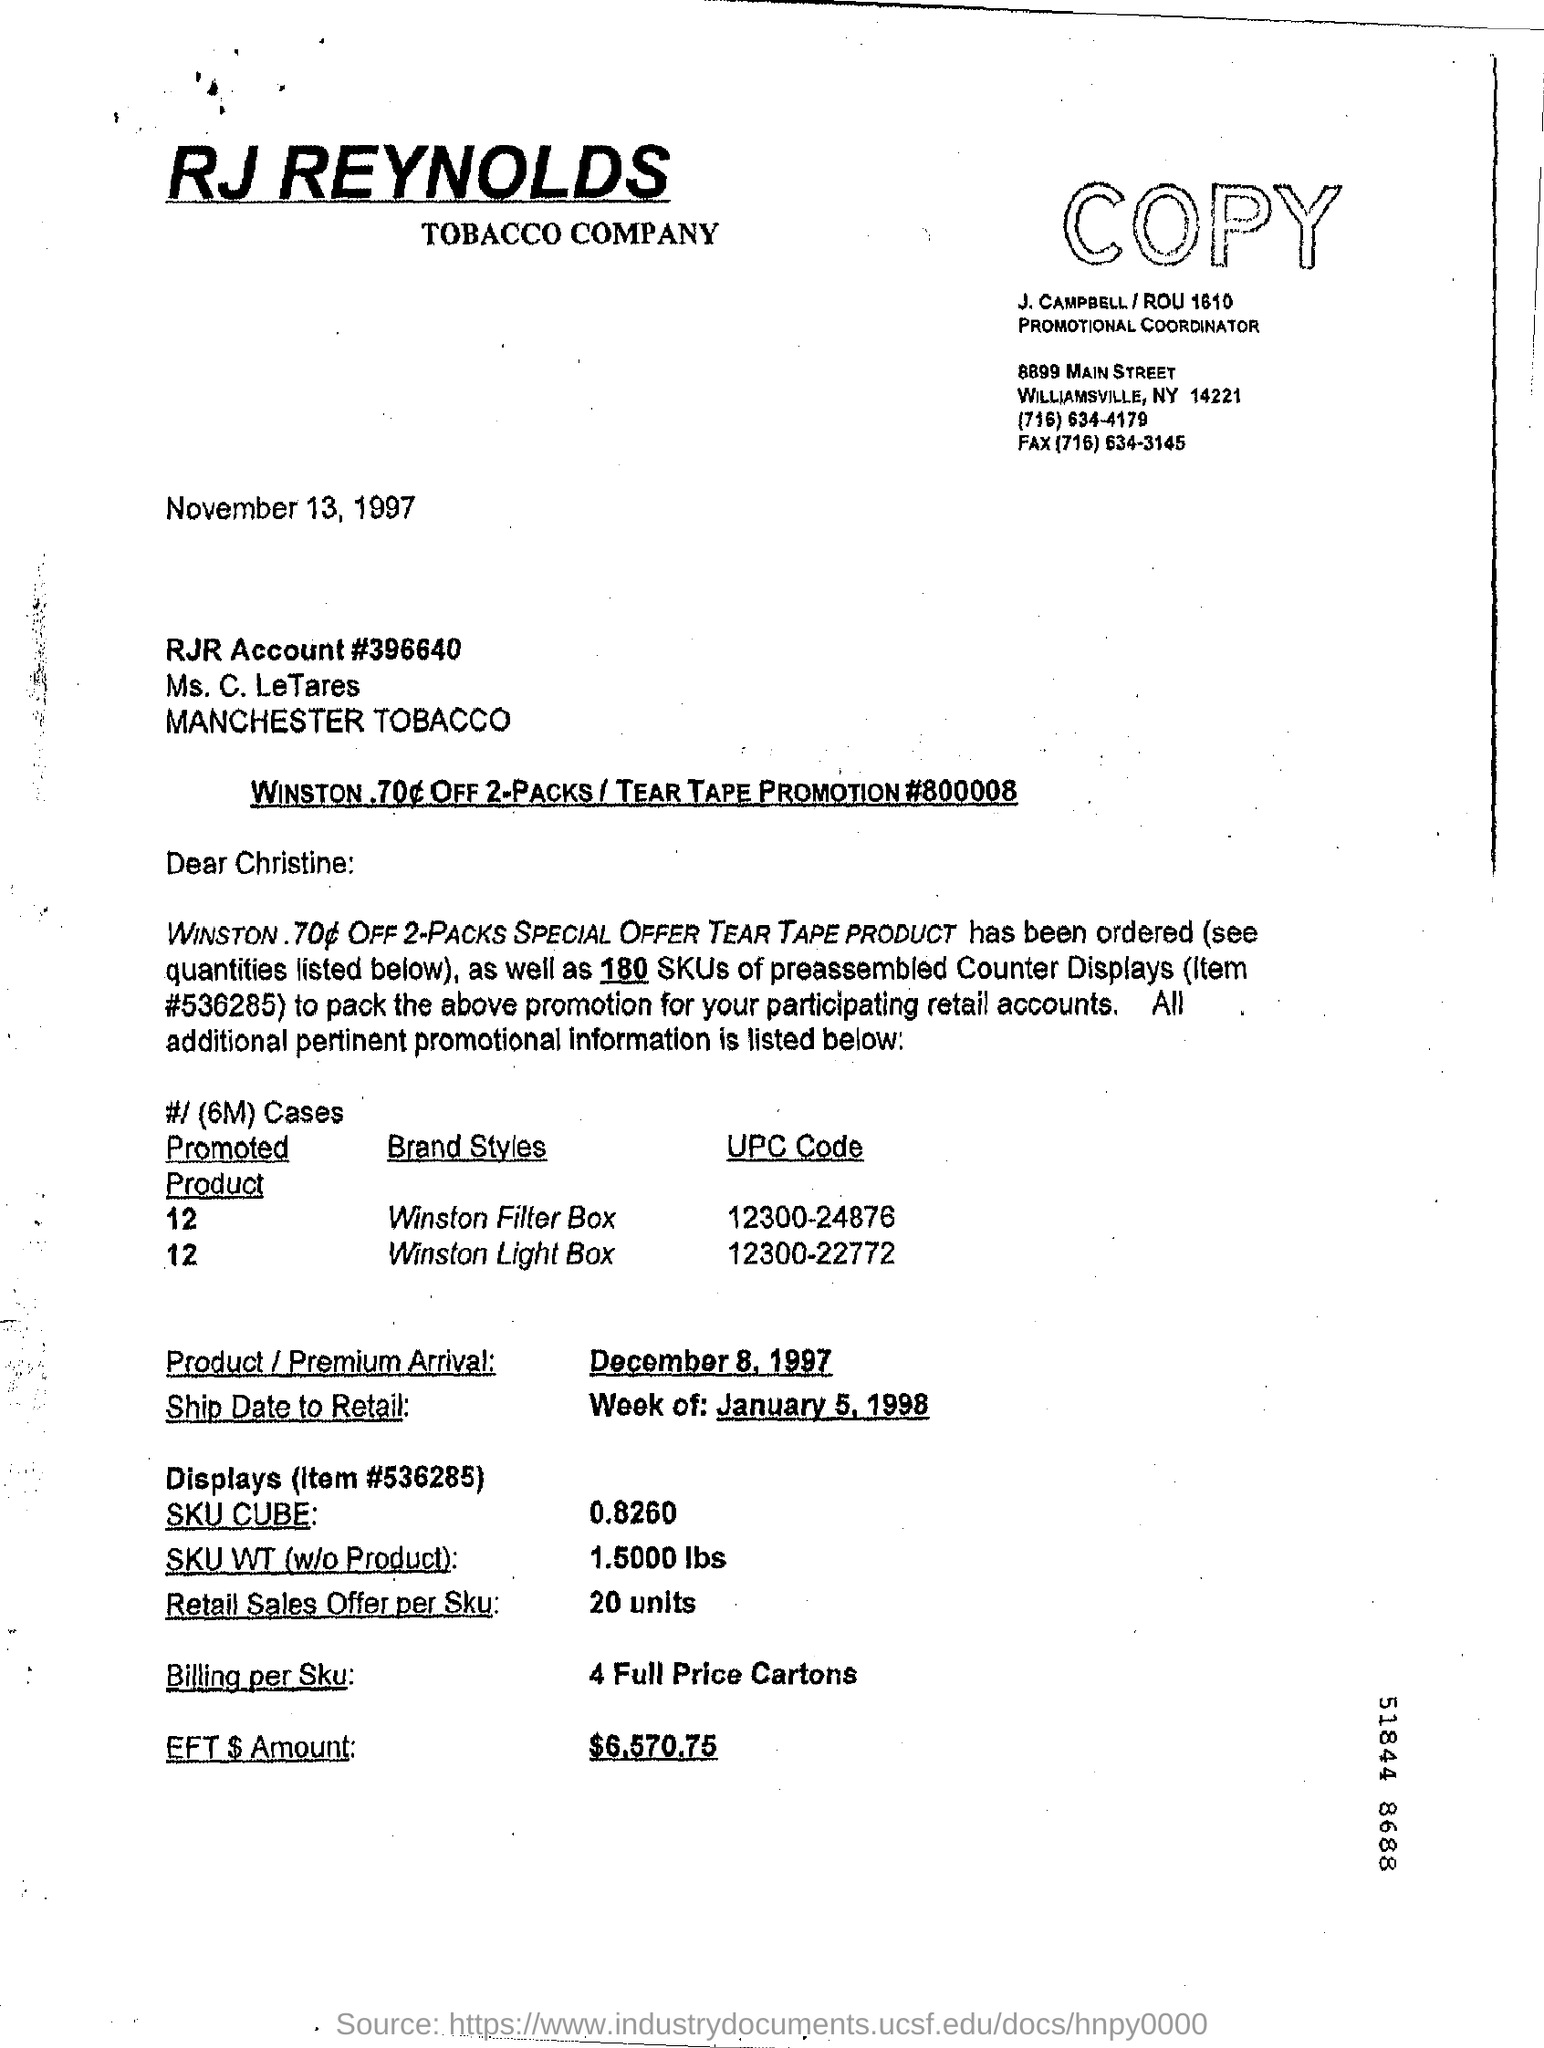What is the date on the document?
 november 13 , 1997 